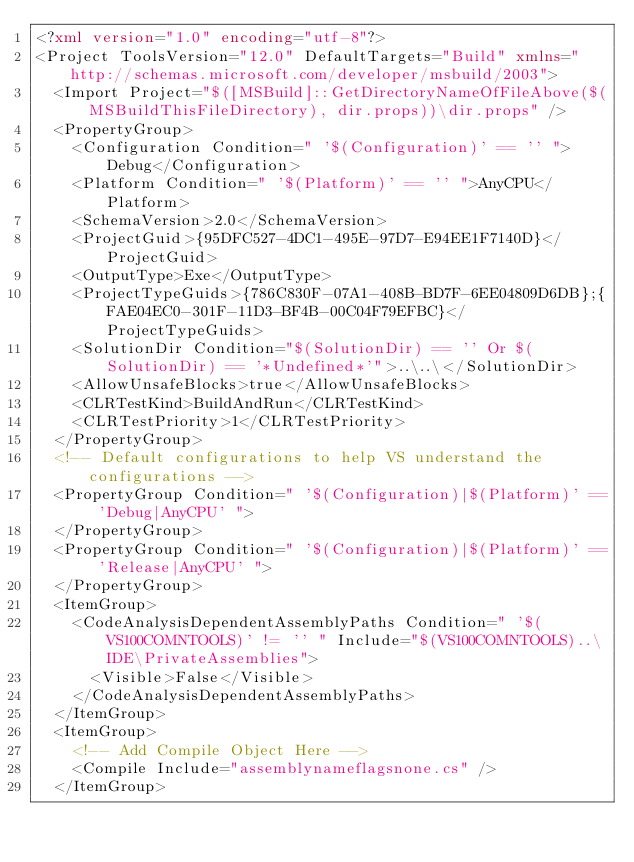<code> <loc_0><loc_0><loc_500><loc_500><_XML_><?xml version="1.0" encoding="utf-8"?>
<Project ToolsVersion="12.0" DefaultTargets="Build" xmlns="http://schemas.microsoft.com/developer/msbuild/2003">
  <Import Project="$([MSBuild]::GetDirectoryNameOfFileAbove($(MSBuildThisFileDirectory), dir.props))\dir.props" />
  <PropertyGroup>
    <Configuration Condition=" '$(Configuration)' == '' ">Debug</Configuration>
    <Platform Condition=" '$(Platform)' == '' ">AnyCPU</Platform>
    <SchemaVersion>2.0</SchemaVersion>
    <ProjectGuid>{95DFC527-4DC1-495E-97D7-E94EE1F7140D}</ProjectGuid>
    <OutputType>Exe</OutputType>
    <ProjectTypeGuids>{786C830F-07A1-408B-BD7F-6EE04809D6DB};{FAE04EC0-301F-11D3-BF4B-00C04F79EFBC}</ProjectTypeGuids>
    <SolutionDir Condition="$(SolutionDir) == '' Or $(SolutionDir) == '*Undefined*'">..\..\</SolutionDir>
    <AllowUnsafeBlocks>true</AllowUnsafeBlocks>
    <CLRTestKind>BuildAndRun</CLRTestKind>
    <CLRTestPriority>1</CLRTestPriority>
  </PropertyGroup>
  <!-- Default configurations to help VS understand the configurations -->
  <PropertyGroup Condition=" '$(Configuration)|$(Platform)' == 'Debug|AnyCPU' ">
  </PropertyGroup>
  <PropertyGroup Condition=" '$(Configuration)|$(Platform)' == 'Release|AnyCPU' ">
  </PropertyGroup>
  <ItemGroup>
    <CodeAnalysisDependentAssemblyPaths Condition=" '$(VS100COMNTOOLS)' != '' " Include="$(VS100COMNTOOLS)..\IDE\PrivateAssemblies">
      <Visible>False</Visible>
    </CodeAnalysisDependentAssemblyPaths>
  </ItemGroup>
  <ItemGroup>
    <!-- Add Compile Object Here -->
    <Compile Include="assemblynameflagsnone.cs" />
  </ItemGroup></code> 